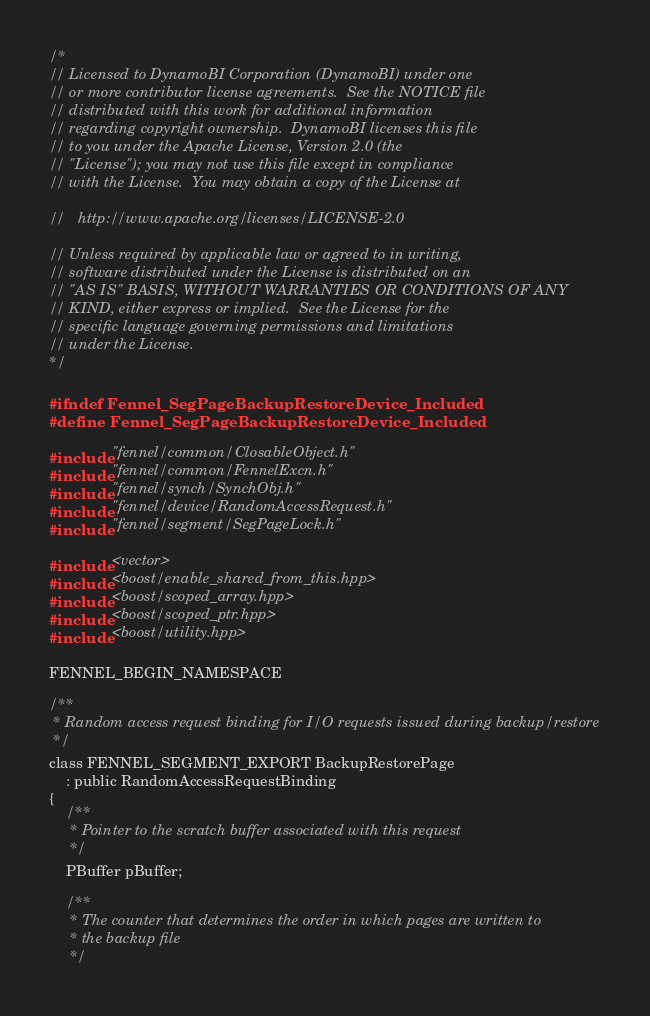Convert code to text. <code><loc_0><loc_0><loc_500><loc_500><_C_>/*
// Licensed to DynamoBI Corporation (DynamoBI) under one
// or more contributor license agreements.  See the NOTICE file
// distributed with this work for additional information
// regarding copyright ownership.  DynamoBI licenses this file
// to you under the Apache License, Version 2.0 (the
// "License"); you may not use this file except in compliance
// with the License.  You may obtain a copy of the License at

//   http://www.apache.org/licenses/LICENSE-2.0

// Unless required by applicable law or agreed to in writing,
// software distributed under the License is distributed on an
// "AS IS" BASIS, WITHOUT WARRANTIES OR CONDITIONS OF ANY
// KIND, either express or implied.  See the License for the
// specific language governing permissions and limitations
// under the License.
*/

#ifndef Fennel_SegPageBackupRestoreDevice_Included
#define Fennel_SegPageBackupRestoreDevice_Included

#include "fennel/common/ClosableObject.h"
#include "fennel/common/FennelExcn.h"
#include "fennel/synch/SynchObj.h"
#include "fennel/device/RandomAccessRequest.h"
#include "fennel/segment/SegPageLock.h"

#include <vector>
#include <boost/enable_shared_from_this.hpp>
#include <boost/scoped_array.hpp>
#include <boost/scoped_ptr.hpp>
#include <boost/utility.hpp>

FENNEL_BEGIN_NAMESPACE

/**
 * Random access request binding for I/O requests issued during backup/restore
 */
class FENNEL_SEGMENT_EXPORT BackupRestorePage
    : public RandomAccessRequestBinding
{
    /**
     * Pointer to the scratch buffer associated with this request
     */
    PBuffer pBuffer;

    /**
     * The counter that determines the order in which pages are written to
     * the backup file
     */</code> 